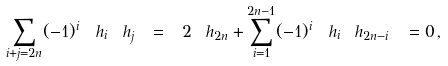<formula> <loc_0><loc_0><loc_500><loc_500>\sum _ { i + j = 2 n } ( - 1 ) ^ { i } \, \ h _ { i } \ h _ { j } \ = \ 2 \ h _ { 2 n } + \sum _ { i = 1 } ^ { 2 n - 1 } ( - 1 ) ^ { i } \, \ h _ { i } \ h _ { 2 n - i } \ = 0 \, ,</formula> 